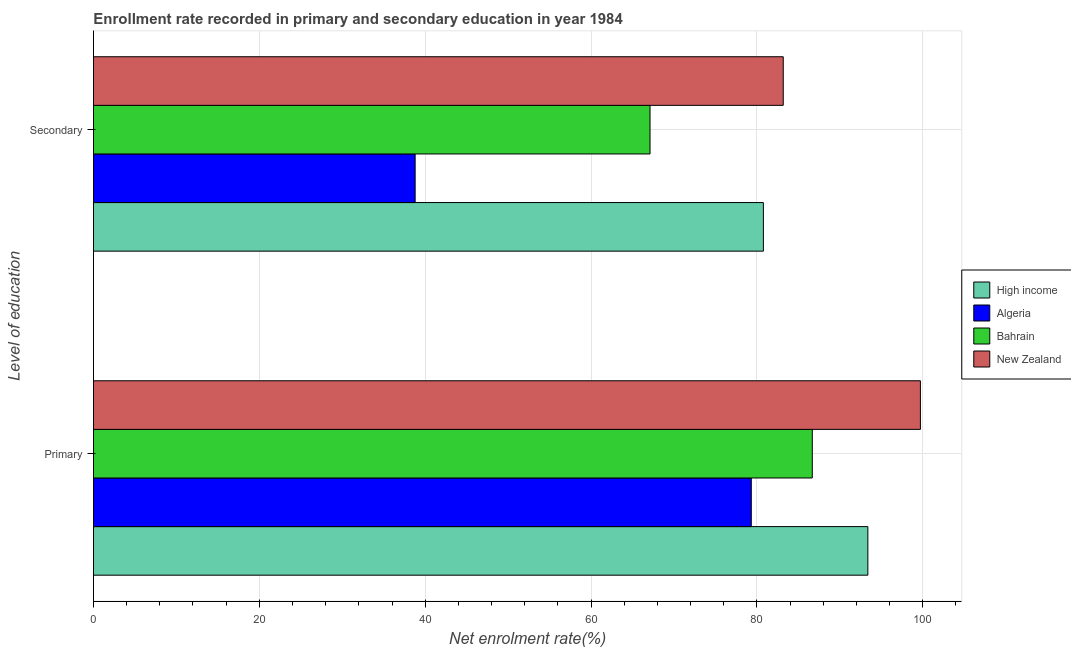How many different coloured bars are there?
Offer a terse response. 4. Are the number of bars on each tick of the Y-axis equal?
Offer a very short reply. Yes. How many bars are there on the 2nd tick from the bottom?
Your answer should be compact. 4. What is the label of the 2nd group of bars from the top?
Make the answer very short. Primary. What is the enrollment rate in primary education in Algeria?
Provide a succinct answer. 79.32. Across all countries, what is the maximum enrollment rate in primary education?
Ensure brevity in your answer.  99.72. Across all countries, what is the minimum enrollment rate in primary education?
Give a very brief answer. 79.32. In which country was the enrollment rate in secondary education maximum?
Your response must be concise. New Zealand. In which country was the enrollment rate in secondary education minimum?
Give a very brief answer. Algeria. What is the total enrollment rate in primary education in the graph?
Keep it short and to the point. 359.1. What is the difference between the enrollment rate in primary education in New Zealand and that in Algeria?
Your answer should be compact. 20.39. What is the difference between the enrollment rate in secondary education in Bahrain and the enrollment rate in primary education in Algeria?
Provide a succinct answer. -12.21. What is the average enrollment rate in secondary education per country?
Your response must be concise. 67.46. What is the difference between the enrollment rate in secondary education and enrollment rate in primary education in High income?
Offer a terse response. -12.6. In how many countries, is the enrollment rate in primary education greater than 32 %?
Your response must be concise. 4. What is the ratio of the enrollment rate in primary education in New Zealand to that in High income?
Keep it short and to the point. 1.07. Is the enrollment rate in primary education in New Zealand less than that in High income?
Offer a very short reply. No. What does the 4th bar from the top in Secondary represents?
Offer a terse response. High income. What does the 1st bar from the bottom in Primary represents?
Your response must be concise. High income. Are all the bars in the graph horizontal?
Give a very brief answer. Yes. What is the difference between two consecutive major ticks on the X-axis?
Your response must be concise. 20. Does the graph contain grids?
Offer a very short reply. Yes. How are the legend labels stacked?
Provide a short and direct response. Vertical. What is the title of the graph?
Offer a very short reply. Enrollment rate recorded in primary and secondary education in year 1984. What is the label or title of the X-axis?
Offer a terse response. Net enrolment rate(%). What is the label or title of the Y-axis?
Your answer should be compact. Level of education. What is the Net enrolment rate(%) of High income in Primary?
Your response must be concise. 93.38. What is the Net enrolment rate(%) in Algeria in Primary?
Your response must be concise. 79.32. What is the Net enrolment rate(%) of Bahrain in Primary?
Your response must be concise. 86.68. What is the Net enrolment rate(%) of New Zealand in Primary?
Offer a terse response. 99.72. What is the Net enrolment rate(%) in High income in Secondary?
Make the answer very short. 80.78. What is the Net enrolment rate(%) in Algeria in Secondary?
Offer a terse response. 38.79. What is the Net enrolment rate(%) of Bahrain in Secondary?
Provide a succinct answer. 67.11. What is the Net enrolment rate(%) in New Zealand in Secondary?
Your response must be concise. 83.18. Across all Level of education, what is the maximum Net enrolment rate(%) in High income?
Offer a terse response. 93.38. Across all Level of education, what is the maximum Net enrolment rate(%) of Algeria?
Offer a very short reply. 79.32. Across all Level of education, what is the maximum Net enrolment rate(%) of Bahrain?
Your answer should be very brief. 86.68. Across all Level of education, what is the maximum Net enrolment rate(%) of New Zealand?
Give a very brief answer. 99.72. Across all Level of education, what is the minimum Net enrolment rate(%) in High income?
Ensure brevity in your answer.  80.78. Across all Level of education, what is the minimum Net enrolment rate(%) in Algeria?
Ensure brevity in your answer.  38.79. Across all Level of education, what is the minimum Net enrolment rate(%) in Bahrain?
Offer a terse response. 67.11. Across all Level of education, what is the minimum Net enrolment rate(%) of New Zealand?
Offer a very short reply. 83.18. What is the total Net enrolment rate(%) in High income in the graph?
Your response must be concise. 174.16. What is the total Net enrolment rate(%) in Algeria in the graph?
Offer a very short reply. 118.11. What is the total Net enrolment rate(%) in Bahrain in the graph?
Your answer should be very brief. 153.79. What is the total Net enrolment rate(%) of New Zealand in the graph?
Make the answer very short. 182.89. What is the difference between the Net enrolment rate(%) of High income in Primary and that in Secondary?
Your response must be concise. 12.6. What is the difference between the Net enrolment rate(%) of Algeria in Primary and that in Secondary?
Offer a very short reply. 40.54. What is the difference between the Net enrolment rate(%) in Bahrain in Primary and that in Secondary?
Give a very brief answer. 19.57. What is the difference between the Net enrolment rate(%) in New Zealand in Primary and that in Secondary?
Give a very brief answer. 16.54. What is the difference between the Net enrolment rate(%) in High income in Primary and the Net enrolment rate(%) in Algeria in Secondary?
Ensure brevity in your answer.  54.59. What is the difference between the Net enrolment rate(%) of High income in Primary and the Net enrolment rate(%) of Bahrain in Secondary?
Offer a very short reply. 26.27. What is the difference between the Net enrolment rate(%) in High income in Primary and the Net enrolment rate(%) in New Zealand in Secondary?
Make the answer very short. 10.2. What is the difference between the Net enrolment rate(%) of Algeria in Primary and the Net enrolment rate(%) of Bahrain in Secondary?
Your answer should be compact. 12.21. What is the difference between the Net enrolment rate(%) in Algeria in Primary and the Net enrolment rate(%) in New Zealand in Secondary?
Make the answer very short. -3.85. What is the difference between the Net enrolment rate(%) in Bahrain in Primary and the Net enrolment rate(%) in New Zealand in Secondary?
Your response must be concise. 3.5. What is the average Net enrolment rate(%) in High income per Level of education?
Keep it short and to the point. 87.08. What is the average Net enrolment rate(%) of Algeria per Level of education?
Offer a very short reply. 59.06. What is the average Net enrolment rate(%) in Bahrain per Level of education?
Your answer should be compact. 76.9. What is the average Net enrolment rate(%) of New Zealand per Level of education?
Offer a very short reply. 91.45. What is the difference between the Net enrolment rate(%) in High income and Net enrolment rate(%) in Algeria in Primary?
Make the answer very short. 14.06. What is the difference between the Net enrolment rate(%) in High income and Net enrolment rate(%) in Bahrain in Primary?
Ensure brevity in your answer.  6.7. What is the difference between the Net enrolment rate(%) of High income and Net enrolment rate(%) of New Zealand in Primary?
Offer a terse response. -6.34. What is the difference between the Net enrolment rate(%) of Algeria and Net enrolment rate(%) of Bahrain in Primary?
Your answer should be compact. -7.36. What is the difference between the Net enrolment rate(%) of Algeria and Net enrolment rate(%) of New Zealand in Primary?
Give a very brief answer. -20.39. What is the difference between the Net enrolment rate(%) in Bahrain and Net enrolment rate(%) in New Zealand in Primary?
Your response must be concise. -13.04. What is the difference between the Net enrolment rate(%) of High income and Net enrolment rate(%) of Algeria in Secondary?
Offer a terse response. 41.99. What is the difference between the Net enrolment rate(%) in High income and Net enrolment rate(%) in Bahrain in Secondary?
Provide a short and direct response. 13.67. What is the difference between the Net enrolment rate(%) in High income and Net enrolment rate(%) in New Zealand in Secondary?
Keep it short and to the point. -2.4. What is the difference between the Net enrolment rate(%) in Algeria and Net enrolment rate(%) in Bahrain in Secondary?
Offer a terse response. -28.32. What is the difference between the Net enrolment rate(%) in Algeria and Net enrolment rate(%) in New Zealand in Secondary?
Ensure brevity in your answer.  -44.39. What is the difference between the Net enrolment rate(%) of Bahrain and Net enrolment rate(%) of New Zealand in Secondary?
Provide a succinct answer. -16.06. What is the ratio of the Net enrolment rate(%) of High income in Primary to that in Secondary?
Your answer should be very brief. 1.16. What is the ratio of the Net enrolment rate(%) in Algeria in Primary to that in Secondary?
Keep it short and to the point. 2.04. What is the ratio of the Net enrolment rate(%) of Bahrain in Primary to that in Secondary?
Ensure brevity in your answer.  1.29. What is the ratio of the Net enrolment rate(%) in New Zealand in Primary to that in Secondary?
Offer a very short reply. 1.2. What is the difference between the highest and the second highest Net enrolment rate(%) of High income?
Provide a succinct answer. 12.6. What is the difference between the highest and the second highest Net enrolment rate(%) in Algeria?
Your answer should be very brief. 40.54. What is the difference between the highest and the second highest Net enrolment rate(%) in Bahrain?
Provide a succinct answer. 19.57. What is the difference between the highest and the second highest Net enrolment rate(%) of New Zealand?
Offer a very short reply. 16.54. What is the difference between the highest and the lowest Net enrolment rate(%) of High income?
Offer a very short reply. 12.6. What is the difference between the highest and the lowest Net enrolment rate(%) of Algeria?
Make the answer very short. 40.54. What is the difference between the highest and the lowest Net enrolment rate(%) of Bahrain?
Offer a terse response. 19.57. What is the difference between the highest and the lowest Net enrolment rate(%) in New Zealand?
Keep it short and to the point. 16.54. 